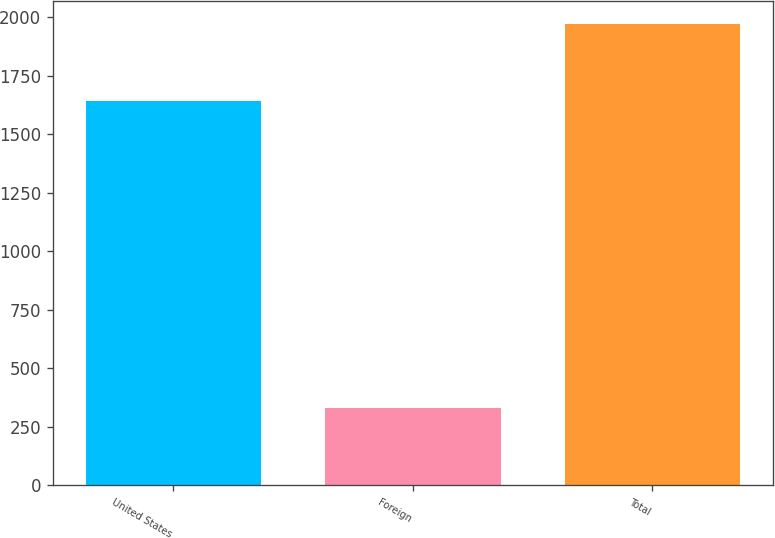Convert chart to OTSL. <chart><loc_0><loc_0><loc_500><loc_500><bar_chart><fcel>United States<fcel>Foreign<fcel>Total<nl><fcel>1640<fcel>330<fcel>1970<nl></chart> 